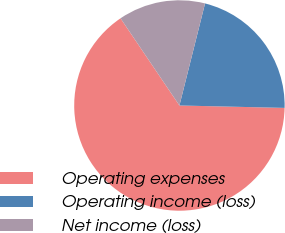Convert chart to OTSL. <chart><loc_0><loc_0><loc_500><loc_500><pie_chart><fcel>Operating expenses<fcel>Operating income (loss)<fcel>Net income (loss)<nl><fcel>65.18%<fcel>21.45%<fcel>13.37%<nl></chart> 